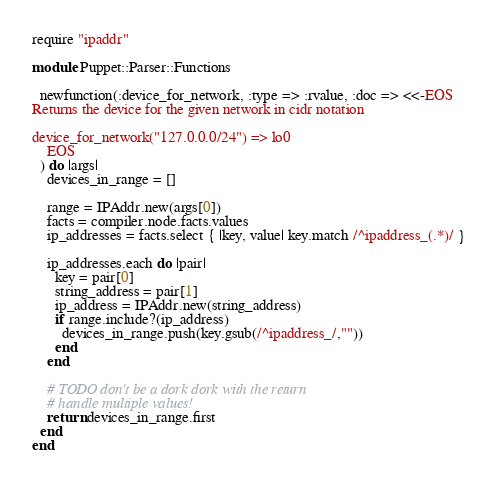Convert code to text. <code><loc_0><loc_0><loc_500><loc_500><_Ruby_>require "ipaddr"

module Puppet::Parser::Functions

  newfunction(:device_for_network, :type => :rvalue, :doc => <<-EOS
Returns the device for the given network in cidr notation

device_for_network("127.0.0.0/24") => lo0
    EOS
  ) do |args| 
    devices_in_range = [] 

    range = IPAddr.new(args[0])
    facts = compiler.node.facts.values
    ip_addresses = facts.select { |key, value| key.match /^ipaddress_(.*)/ }

    ip_addresses.each do |pair|
      key = pair[0]
      string_address = pair[1]
      ip_address = IPAddr.new(string_address)
      if range.include?(ip_address)
        devices_in_range.push(key.gsub(/^ipaddress_/,""))
      end
    end

    # TODO don't be a dork dork with the return
    # handle multiple values!
    return devices_in_range.first
  end
end
</code> 